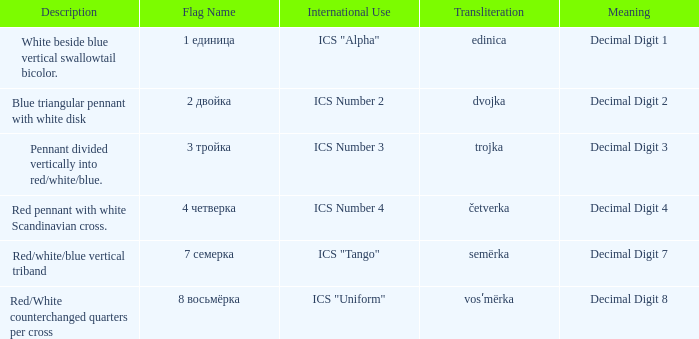What are the meanings of the flag whose name transliterates to semërka? Decimal Digit 7. 